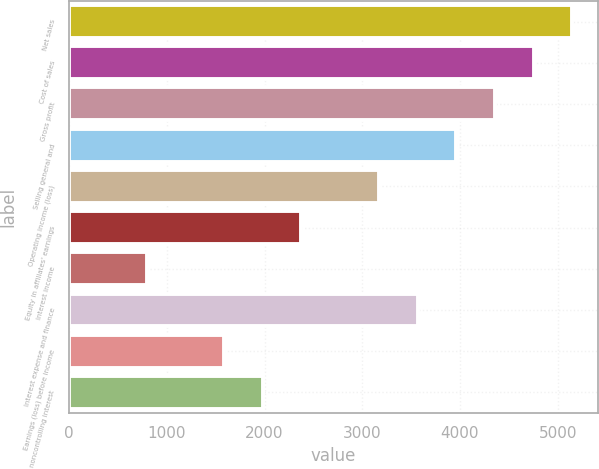Convert chart to OTSL. <chart><loc_0><loc_0><loc_500><loc_500><bar_chart><fcel>Net sales<fcel>Cost of sales<fcel>Gross profit<fcel>Selling general and<fcel>Operating income (loss)<fcel>Equity in affiliates' earnings<fcel>Interest income<fcel>Interest expense and finance<fcel>Earnings (loss) before income<fcel>noncontrolling interest<nl><fcel>5150.31<fcel>4754.15<fcel>4357.99<fcel>3961.83<fcel>3169.51<fcel>2377.19<fcel>792.55<fcel>3565.67<fcel>1584.87<fcel>1981.03<nl></chart> 